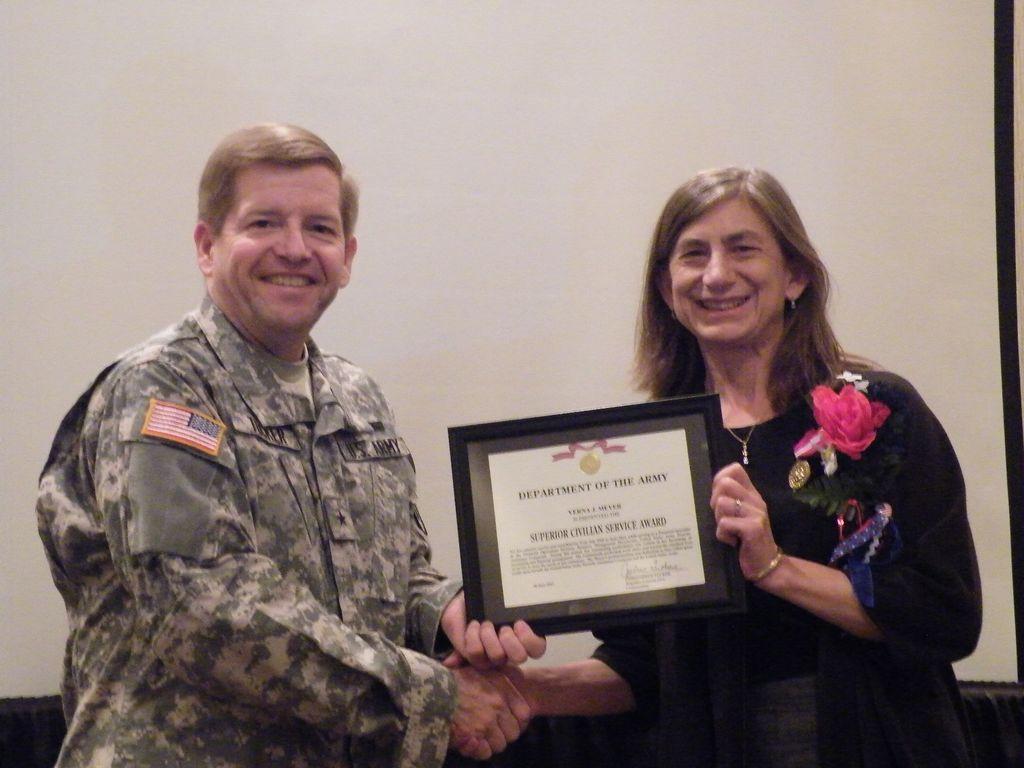How would you summarize this image in a sentence or two? In this image we can see man and woman are shaking hand and holding one frame. Man is wearing army uniform and woman is wearing black color dress. Behind the wall is there. 